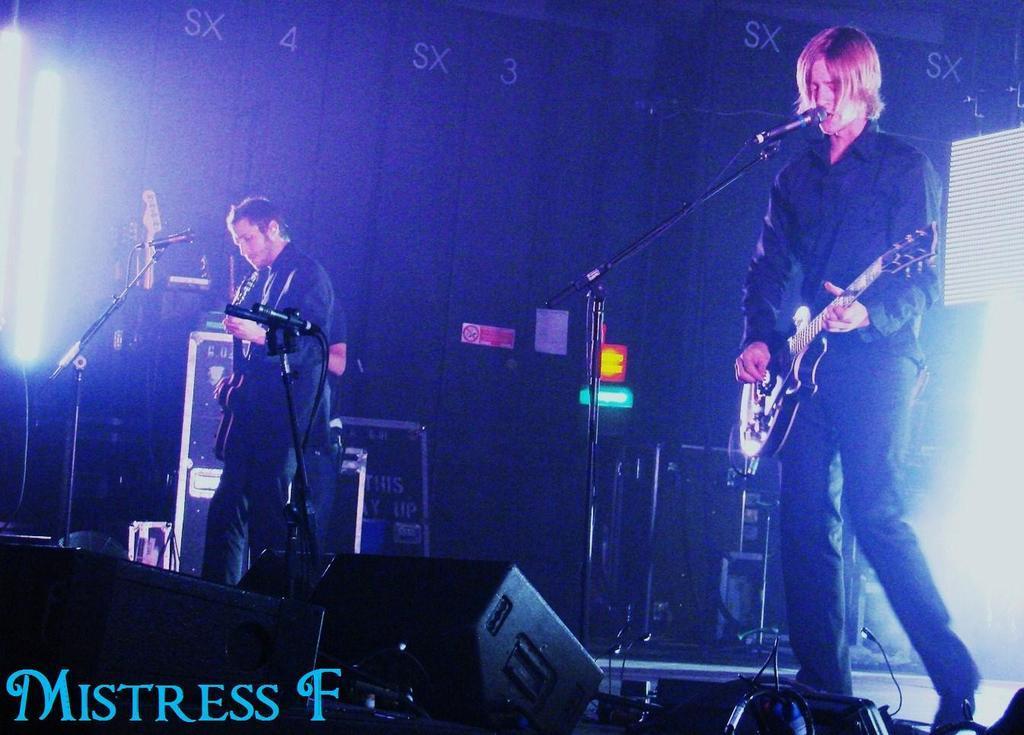How would you summarize this image in a sentence or two? There are two persons, standing, singing, holding and playing guitars, on the stage, on which, there are speakers, mics, which are attached to the stands, lights which are attached to the roof. In front of them, there is watermark. In the background, there are other objects. 